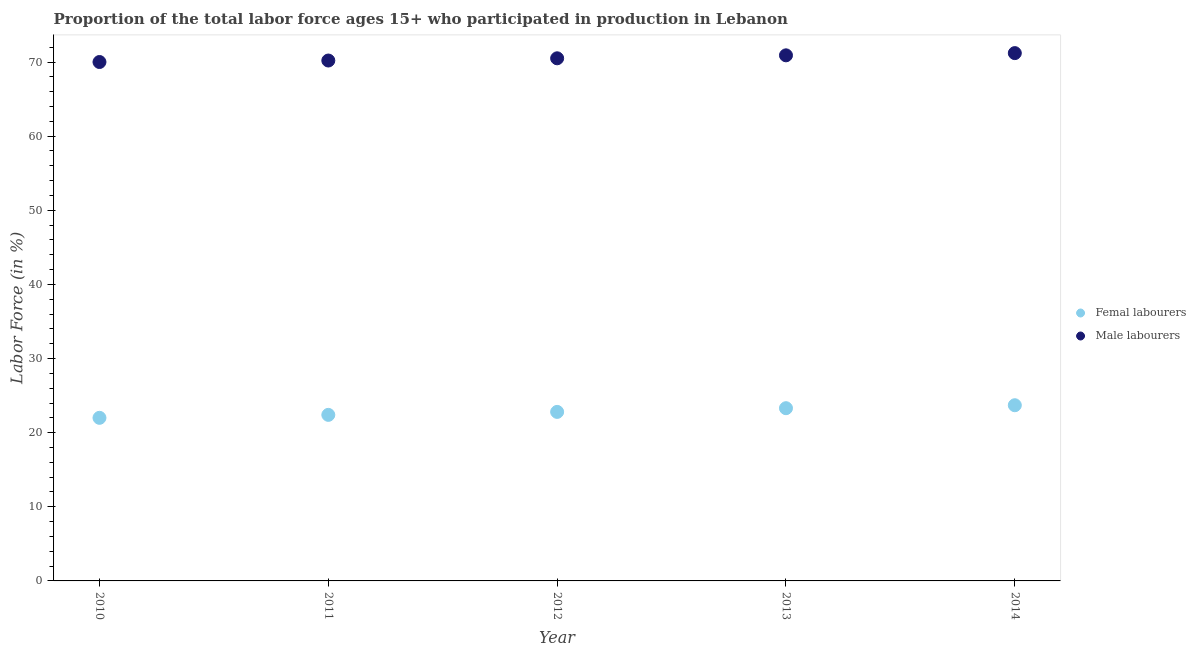How many different coloured dotlines are there?
Your answer should be compact. 2. What is the percentage of male labour force in 2012?
Your answer should be compact. 70.5. Across all years, what is the maximum percentage of female labor force?
Your answer should be compact. 23.7. What is the total percentage of male labour force in the graph?
Offer a very short reply. 352.8. What is the difference between the percentage of female labor force in 2012 and that in 2013?
Provide a succinct answer. -0.5. What is the difference between the percentage of male labour force in 2014 and the percentage of female labor force in 2012?
Keep it short and to the point. 48.4. What is the average percentage of male labour force per year?
Your answer should be compact. 70.56. In the year 2010, what is the difference between the percentage of female labor force and percentage of male labour force?
Provide a short and direct response. -48. In how many years, is the percentage of female labor force greater than 16 %?
Ensure brevity in your answer.  5. What is the ratio of the percentage of female labor force in 2010 to that in 2011?
Your answer should be compact. 0.98. Is the difference between the percentage of female labor force in 2011 and 2013 greater than the difference between the percentage of male labour force in 2011 and 2013?
Ensure brevity in your answer.  No. What is the difference between the highest and the second highest percentage of male labour force?
Your answer should be very brief. 0.3. What is the difference between the highest and the lowest percentage of female labor force?
Provide a short and direct response. 1.7. Is the percentage of female labor force strictly less than the percentage of male labour force over the years?
Provide a short and direct response. Yes. How many years are there in the graph?
Make the answer very short. 5. Are the values on the major ticks of Y-axis written in scientific E-notation?
Your answer should be compact. No. Does the graph contain any zero values?
Provide a short and direct response. No. Where does the legend appear in the graph?
Offer a terse response. Center right. How many legend labels are there?
Your response must be concise. 2. How are the legend labels stacked?
Provide a succinct answer. Vertical. What is the title of the graph?
Offer a terse response. Proportion of the total labor force ages 15+ who participated in production in Lebanon. What is the Labor Force (in %) in Femal labourers in 2011?
Make the answer very short. 22.4. What is the Labor Force (in %) in Male labourers in 2011?
Offer a very short reply. 70.2. What is the Labor Force (in %) in Femal labourers in 2012?
Give a very brief answer. 22.8. What is the Labor Force (in %) in Male labourers in 2012?
Provide a short and direct response. 70.5. What is the Labor Force (in %) of Femal labourers in 2013?
Ensure brevity in your answer.  23.3. What is the Labor Force (in %) of Male labourers in 2013?
Your answer should be compact. 70.9. What is the Labor Force (in %) of Femal labourers in 2014?
Offer a terse response. 23.7. What is the Labor Force (in %) of Male labourers in 2014?
Give a very brief answer. 71.2. Across all years, what is the maximum Labor Force (in %) of Femal labourers?
Offer a terse response. 23.7. Across all years, what is the maximum Labor Force (in %) in Male labourers?
Offer a very short reply. 71.2. What is the total Labor Force (in %) of Femal labourers in the graph?
Offer a terse response. 114.2. What is the total Labor Force (in %) of Male labourers in the graph?
Give a very brief answer. 352.8. What is the difference between the Labor Force (in %) in Femal labourers in 2010 and that in 2011?
Provide a short and direct response. -0.4. What is the difference between the Labor Force (in %) in Male labourers in 2010 and that in 2011?
Provide a short and direct response. -0.2. What is the difference between the Labor Force (in %) in Male labourers in 2010 and that in 2014?
Ensure brevity in your answer.  -1.2. What is the difference between the Labor Force (in %) in Male labourers in 2011 and that in 2012?
Offer a terse response. -0.3. What is the difference between the Labor Force (in %) of Femal labourers in 2011 and that in 2014?
Make the answer very short. -1.3. What is the difference between the Labor Force (in %) of Male labourers in 2011 and that in 2014?
Offer a terse response. -1. What is the difference between the Labor Force (in %) in Male labourers in 2012 and that in 2013?
Keep it short and to the point. -0.4. What is the difference between the Labor Force (in %) in Male labourers in 2012 and that in 2014?
Offer a terse response. -0.7. What is the difference between the Labor Force (in %) in Male labourers in 2013 and that in 2014?
Give a very brief answer. -0.3. What is the difference between the Labor Force (in %) in Femal labourers in 2010 and the Labor Force (in %) in Male labourers in 2011?
Offer a very short reply. -48.2. What is the difference between the Labor Force (in %) of Femal labourers in 2010 and the Labor Force (in %) of Male labourers in 2012?
Provide a short and direct response. -48.5. What is the difference between the Labor Force (in %) of Femal labourers in 2010 and the Labor Force (in %) of Male labourers in 2013?
Your response must be concise. -48.9. What is the difference between the Labor Force (in %) in Femal labourers in 2010 and the Labor Force (in %) in Male labourers in 2014?
Ensure brevity in your answer.  -49.2. What is the difference between the Labor Force (in %) of Femal labourers in 2011 and the Labor Force (in %) of Male labourers in 2012?
Give a very brief answer. -48.1. What is the difference between the Labor Force (in %) in Femal labourers in 2011 and the Labor Force (in %) in Male labourers in 2013?
Give a very brief answer. -48.5. What is the difference between the Labor Force (in %) of Femal labourers in 2011 and the Labor Force (in %) of Male labourers in 2014?
Provide a succinct answer. -48.8. What is the difference between the Labor Force (in %) in Femal labourers in 2012 and the Labor Force (in %) in Male labourers in 2013?
Ensure brevity in your answer.  -48.1. What is the difference between the Labor Force (in %) of Femal labourers in 2012 and the Labor Force (in %) of Male labourers in 2014?
Your response must be concise. -48.4. What is the difference between the Labor Force (in %) of Femal labourers in 2013 and the Labor Force (in %) of Male labourers in 2014?
Your answer should be compact. -47.9. What is the average Labor Force (in %) of Femal labourers per year?
Keep it short and to the point. 22.84. What is the average Labor Force (in %) in Male labourers per year?
Offer a very short reply. 70.56. In the year 2010, what is the difference between the Labor Force (in %) of Femal labourers and Labor Force (in %) of Male labourers?
Your answer should be very brief. -48. In the year 2011, what is the difference between the Labor Force (in %) of Femal labourers and Labor Force (in %) of Male labourers?
Ensure brevity in your answer.  -47.8. In the year 2012, what is the difference between the Labor Force (in %) of Femal labourers and Labor Force (in %) of Male labourers?
Your response must be concise. -47.7. In the year 2013, what is the difference between the Labor Force (in %) of Femal labourers and Labor Force (in %) of Male labourers?
Offer a very short reply. -47.6. In the year 2014, what is the difference between the Labor Force (in %) of Femal labourers and Labor Force (in %) of Male labourers?
Offer a very short reply. -47.5. What is the ratio of the Labor Force (in %) in Femal labourers in 2010 to that in 2011?
Give a very brief answer. 0.98. What is the ratio of the Labor Force (in %) of Male labourers in 2010 to that in 2011?
Keep it short and to the point. 1. What is the ratio of the Labor Force (in %) of Femal labourers in 2010 to that in 2012?
Ensure brevity in your answer.  0.96. What is the ratio of the Labor Force (in %) of Femal labourers in 2010 to that in 2013?
Ensure brevity in your answer.  0.94. What is the ratio of the Labor Force (in %) of Male labourers in 2010 to that in 2013?
Your answer should be compact. 0.99. What is the ratio of the Labor Force (in %) of Femal labourers in 2010 to that in 2014?
Give a very brief answer. 0.93. What is the ratio of the Labor Force (in %) in Male labourers in 2010 to that in 2014?
Ensure brevity in your answer.  0.98. What is the ratio of the Labor Force (in %) in Femal labourers in 2011 to that in 2012?
Offer a very short reply. 0.98. What is the ratio of the Labor Force (in %) in Femal labourers in 2011 to that in 2013?
Provide a short and direct response. 0.96. What is the ratio of the Labor Force (in %) of Femal labourers in 2011 to that in 2014?
Provide a succinct answer. 0.95. What is the ratio of the Labor Force (in %) of Male labourers in 2011 to that in 2014?
Offer a terse response. 0.99. What is the ratio of the Labor Force (in %) of Femal labourers in 2012 to that in 2013?
Provide a succinct answer. 0.98. What is the ratio of the Labor Force (in %) in Male labourers in 2012 to that in 2013?
Your answer should be compact. 0.99. What is the ratio of the Labor Force (in %) of Femal labourers in 2012 to that in 2014?
Provide a short and direct response. 0.96. What is the ratio of the Labor Force (in %) in Male labourers in 2012 to that in 2014?
Ensure brevity in your answer.  0.99. What is the ratio of the Labor Force (in %) of Femal labourers in 2013 to that in 2014?
Your answer should be compact. 0.98. What is the ratio of the Labor Force (in %) in Male labourers in 2013 to that in 2014?
Your response must be concise. 1. What is the difference between the highest and the second highest Labor Force (in %) of Femal labourers?
Provide a short and direct response. 0.4. What is the difference between the highest and the lowest Labor Force (in %) in Femal labourers?
Ensure brevity in your answer.  1.7. What is the difference between the highest and the lowest Labor Force (in %) of Male labourers?
Make the answer very short. 1.2. 